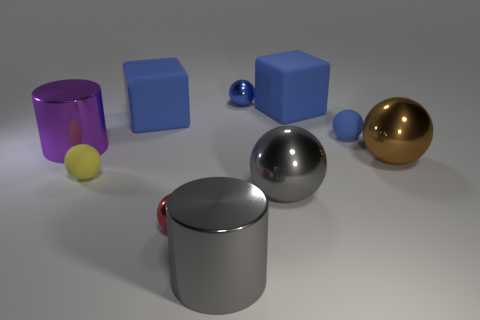Which objects in the image reflect light most intensely? The metallic sphere and the cylinder on the bottom left exhibit the most intense reflections, indicating they might have the smoothest and most polished surfaces among the objects. 